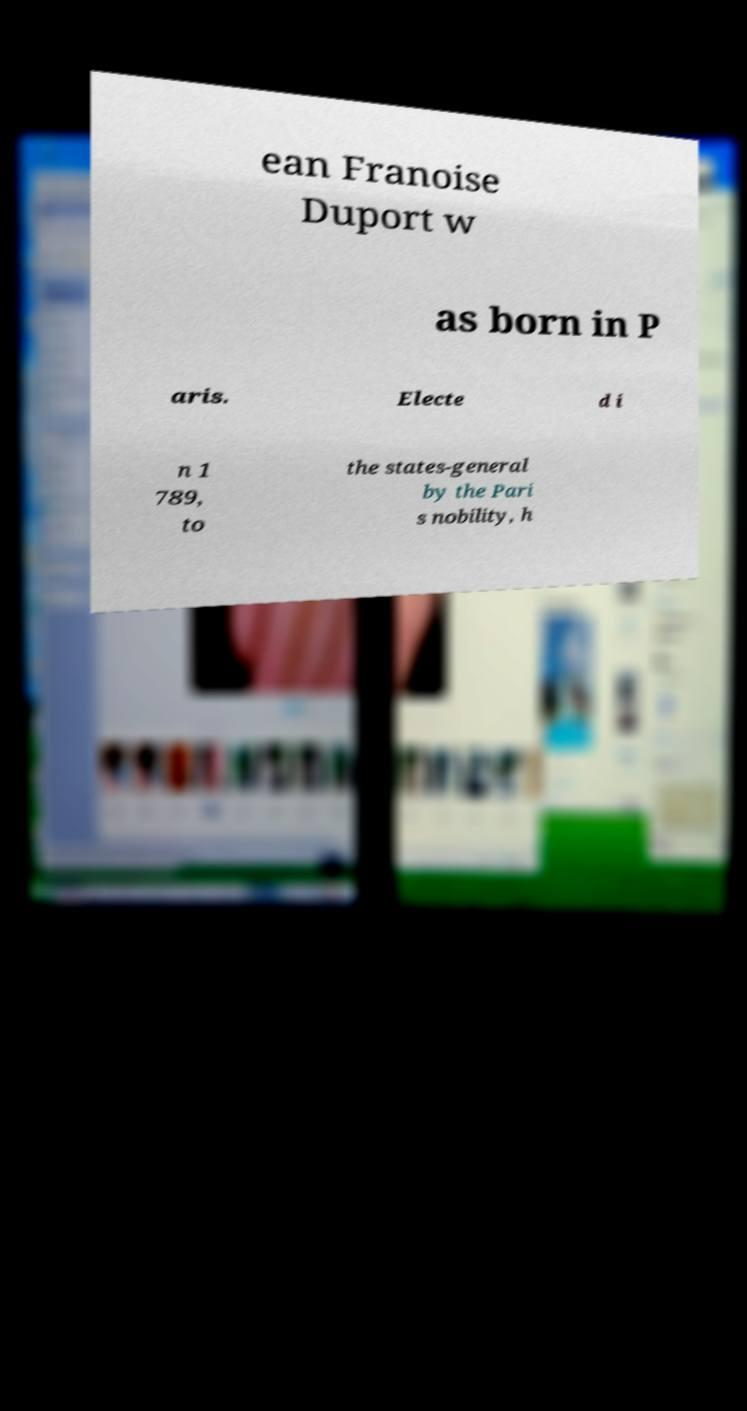Please read and relay the text visible in this image. What does it say? ean Franoise Duport w as born in P aris. Electe d i n 1 789, to the states-general by the Pari s nobility, h 